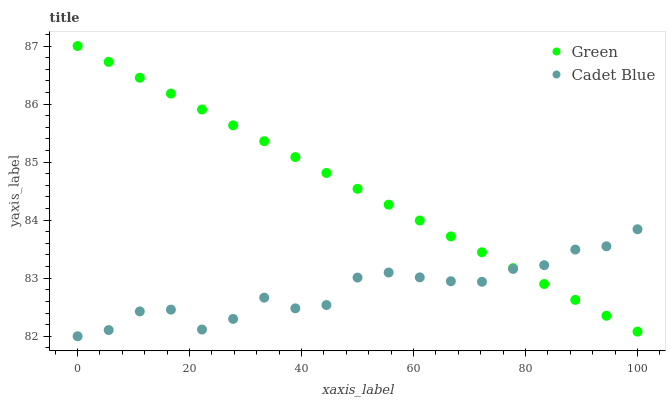Does Cadet Blue have the minimum area under the curve?
Answer yes or no. Yes. Does Green have the maximum area under the curve?
Answer yes or no. Yes. Does Green have the minimum area under the curve?
Answer yes or no. No. Is Green the smoothest?
Answer yes or no. Yes. Is Cadet Blue the roughest?
Answer yes or no. Yes. Is Green the roughest?
Answer yes or no. No. Does Cadet Blue have the lowest value?
Answer yes or no. Yes. Does Green have the lowest value?
Answer yes or no. No. Does Green have the highest value?
Answer yes or no. Yes. Does Cadet Blue intersect Green?
Answer yes or no. Yes. Is Cadet Blue less than Green?
Answer yes or no. No. Is Cadet Blue greater than Green?
Answer yes or no. No. 